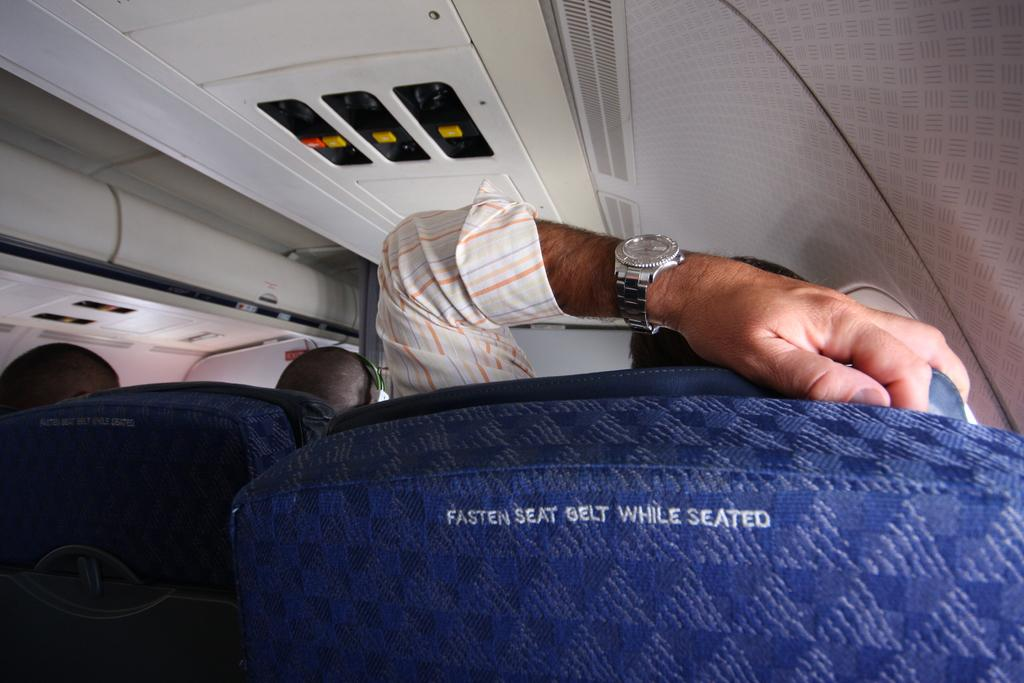Where was the image taken? The image was taken inside an aeroplane. What can be observed about the people inside the aeroplane? There are people sitting inside the aeroplane. What type of dress is the engine wearing in the image? There is no engine present in the image, and therefore no dress or any other clothing item can be associated with it. 